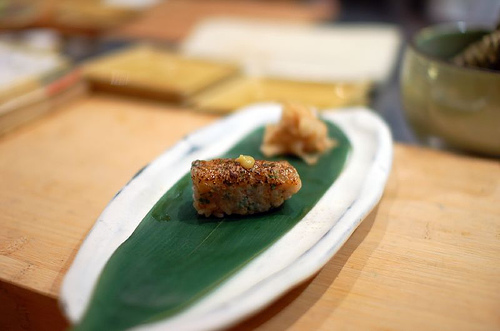<image>
Is the sushi on the table? Yes. Looking at the image, I can see the sushi is positioned on top of the table, with the table providing support. 